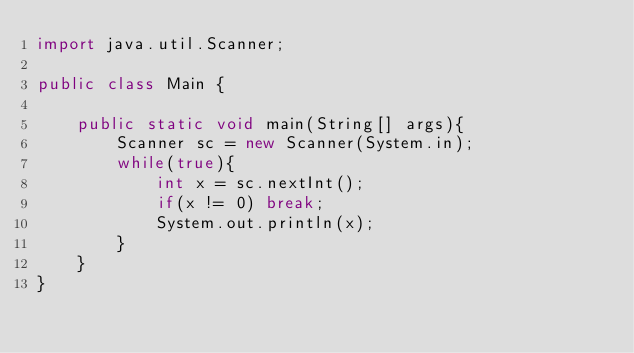<code> <loc_0><loc_0><loc_500><loc_500><_Java_>import java.util.Scanner;

public class Main {

	public static void main(String[] args){
		Scanner sc = new Scanner(System.in);
		while(true){
			int x = sc.nextInt();
			if(x != 0) break;
			System.out.println(x);
		}
	}
}</code> 